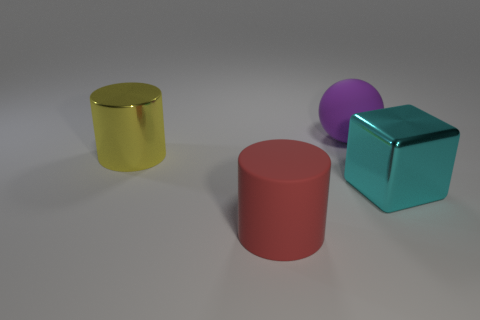There is a big purple rubber thing; is its shape the same as the matte thing in front of the big cyan metal thing?
Keep it short and to the point. No. What is the shape of the cyan object that is the same material as the big yellow thing?
Your response must be concise. Cube. Is the number of cyan metallic objects behind the big yellow cylinder greater than the number of red cylinders right of the large matte cylinder?
Make the answer very short. No. What number of things are either tiny purple matte cylinders or big rubber things?
Your answer should be compact. 2. How many other objects are there of the same color as the large rubber ball?
Ensure brevity in your answer.  0. The red object that is the same size as the yellow metallic cylinder is what shape?
Offer a very short reply. Cylinder. The large thing that is behind the large yellow metal thing is what color?
Your answer should be very brief. Purple. What number of objects are either large rubber things on the left side of the big purple matte sphere or objects to the right of the metallic cylinder?
Ensure brevity in your answer.  3. Is the shiny cylinder the same size as the purple rubber ball?
Your answer should be very brief. Yes. How many spheres are either large cyan metal objects or big yellow metallic objects?
Provide a succinct answer. 0. 